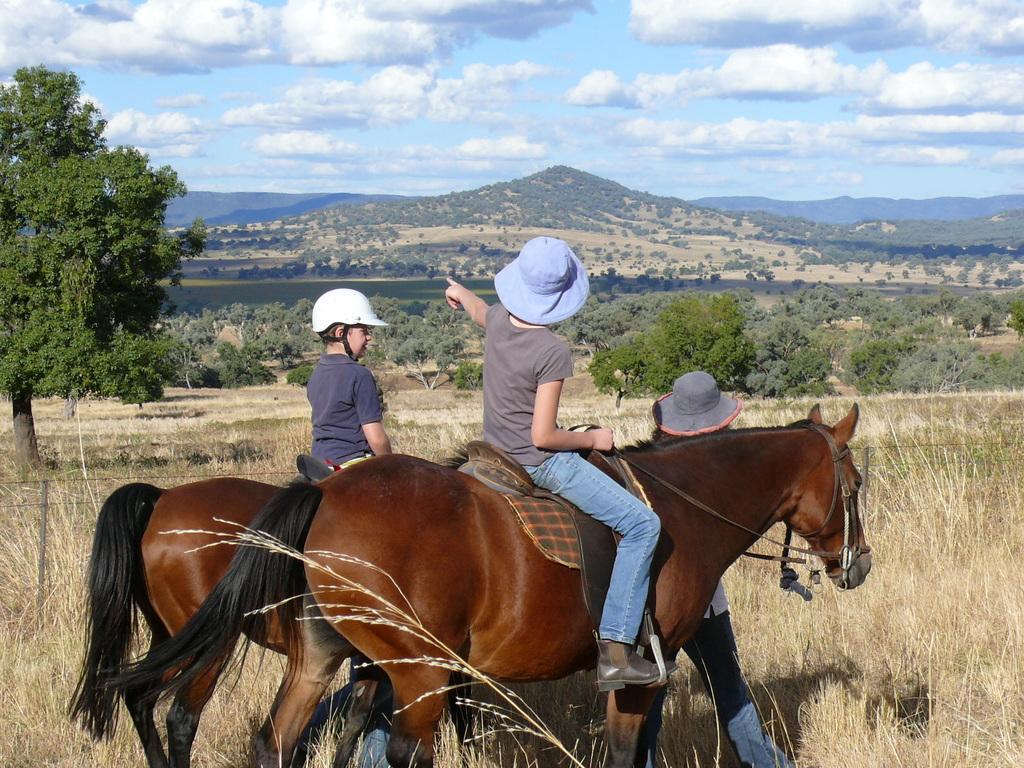Describe this image in one or two sentences. In this picture we can see people,two people are sitting on horses and in the background we can see trees,sky. 